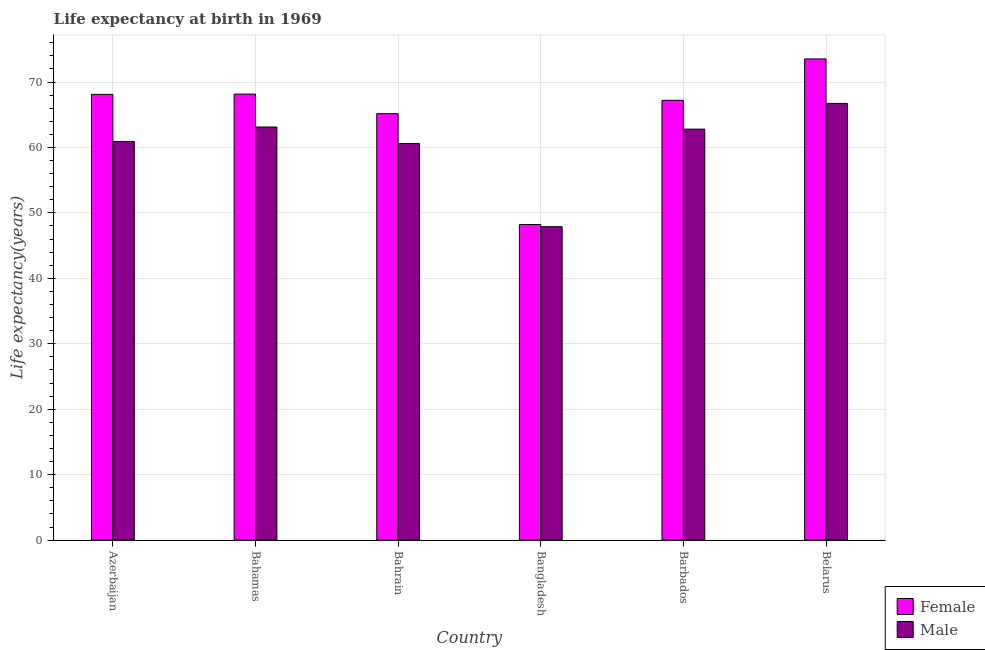How many bars are there on the 6th tick from the left?
Provide a short and direct response. 2. What is the label of the 5th group of bars from the left?
Offer a very short reply. Barbados. In how many cases, is the number of bars for a given country not equal to the number of legend labels?
Your answer should be compact. 0. What is the life expectancy(male) in Bahamas?
Keep it short and to the point. 63.12. Across all countries, what is the maximum life expectancy(female)?
Offer a terse response. 73.53. Across all countries, what is the minimum life expectancy(male)?
Offer a terse response. 47.89. In which country was the life expectancy(female) maximum?
Provide a short and direct response. Belarus. In which country was the life expectancy(female) minimum?
Keep it short and to the point. Bangladesh. What is the total life expectancy(male) in the graph?
Keep it short and to the point. 362.04. What is the difference between the life expectancy(female) in Bangladesh and that in Barbados?
Your response must be concise. -18.98. What is the difference between the life expectancy(male) in Bahamas and the life expectancy(female) in Bahrain?
Give a very brief answer. -2.03. What is the average life expectancy(female) per country?
Ensure brevity in your answer.  65.06. What is the difference between the life expectancy(female) and life expectancy(male) in Bangladesh?
Make the answer very short. 0.33. In how many countries, is the life expectancy(female) greater than 64 years?
Your answer should be very brief. 5. What is the ratio of the life expectancy(female) in Bangladesh to that in Belarus?
Offer a very short reply. 0.66. Is the difference between the life expectancy(male) in Azerbaijan and Bahamas greater than the difference between the life expectancy(female) in Azerbaijan and Bahamas?
Make the answer very short. No. What is the difference between the highest and the second highest life expectancy(female)?
Your response must be concise. 5.37. What is the difference between the highest and the lowest life expectancy(female)?
Offer a very short reply. 25.31. Is the sum of the life expectancy(female) in Azerbaijan and Belarus greater than the maximum life expectancy(male) across all countries?
Your answer should be compact. Yes. What does the 1st bar from the left in Azerbaijan represents?
Offer a terse response. Female. What does the 1st bar from the right in Bangladesh represents?
Your answer should be compact. Male. How many bars are there?
Give a very brief answer. 12. How many countries are there in the graph?
Give a very brief answer. 6. Does the graph contain any zero values?
Give a very brief answer. No. What is the title of the graph?
Offer a terse response. Life expectancy at birth in 1969. Does "Register a business" appear as one of the legend labels in the graph?
Provide a short and direct response. No. What is the label or title of the X-axis?
Offer a terse response. Country. What is the label or title of the Y-axis?
Make the answer very short. Life expectancy(years). What is the Life expectancy(years) of Female in Azerbaijan?
Keep it short and to the point. 68.11. What is the Life expectancy(years) in Male in Azerbaijan?
Ensure brevity in your answer.  60.91. What is the Life expectancy(years) of Female in Bahamas?
Your answer should be very brief. 68.15. What is the Life expectancy(years) of Male in Bahamas?
Your response must be concise. 63.12. What is the Life expectancy(years) in Female in Bahrain?
Your answer should be compact. 65.16. What is the Life expectancy(years) of Male in Bahrain?
Offer a terse response. 60.59. What is the Life expectancy(years) of Female in Bangladesh?
Give a very brief answer. 48.22. What is the Life expectancy(years) of Male in Bangladesh?
Keep it short and to the point. 47.89. What is the Life expectancy(years) in Female in Barbados?
Give a very brief answer. 67.2. What is the Life expectancy(years) in Male in Barbados?
Make the answer very short. 62.8. What is the Life expectancy(years) of Female in Belarus?
Give a very brief answer. 73.53. What is the Life expectancy(years) of Male in Belarus?
Make the answer very short. 66.73. Across all countries, what is the maximum Life expectancy(years) in Female?
Offer a terse response. 73.53. Across all countries, what is the maximum Life expectancy(years) in Male?
Give a very brief answer. 66.73. Across all countries, what is the minimum Life expectancy(years) of Female?
Offer a very short reply. 48.22. Across all countries, what is the minimum Life expectancy(years) of Male?
Ensure brevity in your answer.  47.89. What is the total Life expectancy(years) of Female in the graph?
Ensure brevity in your answer.  390.36. What is the total Life expectancy(years) of Male in the graph?
Your answer should be very brief. 362.04. What is the difference between the Life expectancy(years) in Female in Azerbaijan and that in Bahamas?
Offer a terse response. -0.04. What is the difference between the Life expectancy(years) of Male in Azerbaijan and that in Bahamas?
Keep it short and to the point. -2.22. What is the difference between the Life expectancy(years) of Female in Azerbaijan and that in Bahrain?
Offer a terse response. 2.95. What is the difference between the Life expectancy(years) in Male in Azerbaijan and that in Bahrain?
Ensure brevity in your answer.  0.32. What is the difference between the Life expectancy(years) of Female in Azerbaijan and that in Bangladesh?
Give a very brief answer. 19.89. What is the difference between the Life expectancy(years) of Male in Azerbaijan and that in Bangladesh?
Make the answer very short. 13.01. What is the difference between the Life expectancy(years) in Female in Azerbaijan and that in Barbados?
Offer a terse response. 0.91. What is the difference between the Life expectancy(years) in Male in Azerbaijan and that in Barbados?
Ensure brevity in your answer.  -1.89. What is the difference between the Life expectancy(years) in Female in Azerbaijan and that in Belarus?
Provide a short and direct response. -5.42. What is the difference between the Life expectancy(years) in Male in Azerbaijan and that in Belarus?
Provide a succinct answer. -5.83. What is the difference between the Life expectancy(years) of Female in Bahamas and that in Bahrain?
Your answer should be compact. 3. What is the difference between the Life expectancy(years) of Male in Bahamas and that in Bahrain?
Your response must be concise. 2.54. What is the difference between the Life expectancy(years) in Female in Bahamas and that in Bangladesh?
Provide a short and direct response. 19.93. What is the difference between the Life expectancy(years) in Male in Bahamas and that in Bangladesh?
Provide a short and direct response. 15.23. What is the difference between the Life expectancy(years) of Female in Bahamas and that in Barbados?
Provide a succinct answer. 0.95. What is the difference between the Life expectancy(years) of Male in Bahamas and that in Barbados?
Keep it short and to the point. 0.33. What is the difference between the Life expectancy(years) of Female in Bahamas and that in Belarus?
Your answer should be compact. -5.37. What is the difference between the Life expectancy(years) in Male in Bahamas and that in Belarus?
Your answer should be compact. -3.61. What is the difference between the Life expectancy(years) in Female in Bahrain and that in Bangladesh?
Provide a short and direct response. 16.94. What is the difference between the Life expectancy(years) in Male in Bahrain and that in Bangladesh?
Give a very brief answer. 12.7. What is the difference between the Life expectancy(years) in Female in Bahrain and that in Barbados?
Your answer should be compact. -2.04. What is the difference between the Life expectancy(years) of Male in Bahrain and that in Barbados?
Ensure brevity in your answer.  -2.21. What is the difference between the Life expectancy(years) of Female in Bahrain and that in Belarus?
Offer a terse response. -8.37. What is the difference between the Life expectancy(years) of Male in Bahrain and that in Belarus?
Offer a very short reply. -6.14. What is the difference between the Life expectancy(years) of Female in Bangladesh and that in Barbados?
Offer a terse response. -18.98. What is the difference between the Life expectancy(years) in Male in Bangladesh and that in Barbados?
Make the answer very short. -14.9. What is the difference between the Life expectancy(years) of Female in Bangladesh and that in Belarus?
Provide a succinct answer. -25.31. What is the difference between the Life expectancy(years) of Male in Bangladesh and that in Belarus?
Your answer should be very brief. -18.84. What is the difference between the Life expectancy(years) in Female in Barbados and that in Belarus?
Keep it short and to the point. -6.32. What is the difference between the Life expectancy(years) in Male in Barbados and that in Belarus?
Your answer should be compact. -3.93. What is the difference between the Life expectancy(years) in Female in Azerbaijan and the Life expectancy(years) in Male in Bahamas?
Ensure brevity in your answer.  4.98. What is the difference between the Life expectancy(years) in Female in Azerbaijan and the Life expectancy(years) in Male in Bahrain?
Offer a very short reply. 7.52. What is the difference between the Life expectancy(years) of Female in Azerbaijan and the Life expectancy(years) of Male in Bangladesh?
Keep it short and to the point. 20.21. What is the difference between the Life expectancy(years) in Female in Azerbaijan and the Life expectancy(years) in Male in Barbados?
Offer a very short reply. 5.31. What is the difference between the Life expectancy(years) in Female in Azerbaijan and the Life expectancy(years) in Male in Belarus?
Offer a very short reply. 1.38. What is the difference between the Life expectancy(years) in Female in Bahamas and the Life expectancy(years) in Male in Bahrain?
Make the answer very short. 7.56. What is the difference between the Life expectancy(years) of Female in Bahamas and the Life expectancy(years) of Male in Bangladesh?
Provide a succinct answer. 20.26. What is the difference between the Life expectancy(years) in Female in Bahamas and the Life expectancy(years) in Male in Barbados?
Provide a short and direct response. 5.36. What is the difference between the Life expectancy(years) of Female in Bahamas and the Life expectancy(years) of Male in Belarus?
Offer a very short reply. 1.42. What is the difference between the Life expectancy(years) in Female in Bahrain and the Life expectancy(years) in Male in Bangladesh?
Offer a very short reply. 17.26. What is the difference between the Life expectancy(years) in Female in Bahrain and the Life expectancy(years) in Male in Barbados?
Your answer should be compact. 2.36. What is the difference between the Life expectancy(years) of Female in Bahrain and the Life expectancy(years) of Male in Belarus?
Give a very brief answer. -1.57. What is the difference between the Life expectancy(years) in Female in Bangladesh and the Life expectancy(years) in Male in Barbados?
Offer a terse response. -14.58. What is the difference between the Life expectancy(years) in Female in Bangladesh and the Life expectancy(years) in Male in Belarus?
Provide a succinct answer. -18.51. What is the difference between the Life expectancy(years) in Female in Barbados and the Life expectancy(years) in Male in Belarus?
Provide a short and direct response. 0.47. What is the average Life expectancy(years) in Female per country?
Your answer should be very brief. 65.06. What is the average Life expectancy(years) of Male per country?
Your answer should be compact. 60.34. What is the difference between the Life expectancy(years) in Female and Life expectancy(years) in Male in Azerbaijan?
Offer a very short reply. 7.2. What is the difference between the Life expectancy(years) in Female and Life expectancy(years) in Male in Bahamas?
Your answer should be compact. 5.03. What is the difference between the Life expectancy(years) of Female and Life expectancy(years) of Male in Bahrain?
Ensure brevity in your answer.  4.57. What is the difference between the Life expectancy(years) in Female and Life expectancy(years) in Male in Bangladesh?
Offer a terse response. 0.33. What is the difference between the Life expectancy(years) of Female and Life expectancy(years) of Male in Barbados?
Your response must be concise. 4.41. What is the difference between the Life expectancy(years) of Female and Life expectancy(years) of Male in Belarus?
Keep it short and to the point. 6.79. What is the ratio of the Life expectancy(years) in Female in Azerbaijan to that in Bahamas?
Provide a succinct answer. 1. What is the ratio of the Life expectancy(years) in Male in Azerbaijan to that in Bahamas?
Offer a terse response. 0.96. What is the ratio of the Life expectancy(years) in Female in Azerbaijan to that in Bahrain?
Your response must be concise. 1.05. What is the ratio of the Life expectancy(years) of Male in Azerbaijan to that in Bahrain?
Your answer should be very brief. 1.01. What is the ratio of the Life expectancy(years) of Female in Azerbaijan to that in Bangladesh?
Offer a very short reply. 1.41. What is the ratio of the Life expectancy(years) in Male in Azerbaijan to that in Bangladesh?
Keep it short and to the point. 1.27. What is the ratio of the Life expectancy(years) in Female in Azerbaijan to that in Barbados?
Your answer should be compact. 1.01. What is the ratio of the Life expectancy(years) of Male in Azerbaijan to that in Barbados?
Your answer should be very brief. 0.97. What is the ratio of the Life expectancy(years) in Female in Azerbaijan to that in Belarus?
Give a very brief answer. 0.93. What is the ratio of the Life expectancy(years) of Male in Azerbaijan to that in Belarus?
Provide a succinct answer. 0.91. What is the ratio of the Life expectancy(years) in Female in Bahamas to that in Bahrain?
Provide a succinct answer. 1.05. What is the ratio of the Life expectancy(years) in Male in Bahamas to that in Bahrain?
Offer a terse response. 1.04. What is the ratio of the Life expectancy(years) in Female in Bahamas to that in Bangladesh?
Ensure brevity in your answer.  1.41. What is the ratio of the Life expectancy(years) of Male in Bahamas to that in Bangladesh?
Provide a short and direct response. 1.32. What is the ratio of the Life expectancy(years) in Female in Bahamas to that in Barbados?
Your answer should be compact. 1.01. What is the ratio of the Life expectancy(years) of Female in Bahamas to that in Belarus?
Ensure brevity in your answer.  0.93. What is the ratio of the Life expectancy(years) of Male in Bahamas to that in Belarus?
Give a very brief answer. 0.95. What is the ratio of the Life expectancy(years) in Female in Bahrain to that in Bangladesh?
Offer a terse response. 1.35. What is the ratio of the Life expectancy(years) of Male in Bahrain to that in Bangladesh?
Make the answer very short. 1.27. What is the ratio of the Life expectancy(years) of Female in Bahrain to that in Barbados?
Your answer should be compact. 0.97. What is the ratio of the Life expectancy(years) in Male in Bahrain to that in Barbados?
Offer a terse response. 0.96. What is the ratio of the Life expectancy(years) of Female in Bahrain to that in Belarus?
Provide a short and direct response. 0.89. What is the ratio of the Life expectancy(years) of Male in Bahrain to that in Belarus?
Your answer should be compact. 0.91. What is the ratio of the Life expectancy(years) of Female in Bangladesh to that in Barbados?
Make the answer very short. 0.72. What is the ratio of the Life expectancy(years) in Male in Bangladesh to that in Barbados?
Provide a short and direct response. 0.76. What is the ratio of the Life expectancy(years) in Female in Bangladesh to that in Belarus?
Ensure brevity in your answer.  0.66. What is the ratio of the Life expectancy(years) of Male in Bangladesh to that in Belarus?
Offer a very short reply. 0.72. What is the ratio of the Life expectancy(years) in Female in Barbados to that in Belarus?
Make the answer very short. 0.91. What is the ratio of the Life expectancy(years) of Male in Barbados to that in Belarus?
Your response must be concise. 0.94. What is the difference between the highest and the second highest Life expectancy(years) in Female?
Make the answer very short. 5.37. What is the difference between the highest and the second highest Life expectancy(years) of Male?
Keep it short and to the point. 3.61. What is the difference between the highest and the lowest Life expectancy(years) in Female?
Give a very brief answer. 25.31. What is the difference between the highest and the lowest Life expectancy(years) of Male?
Provide a succinct answer. 18.84. 